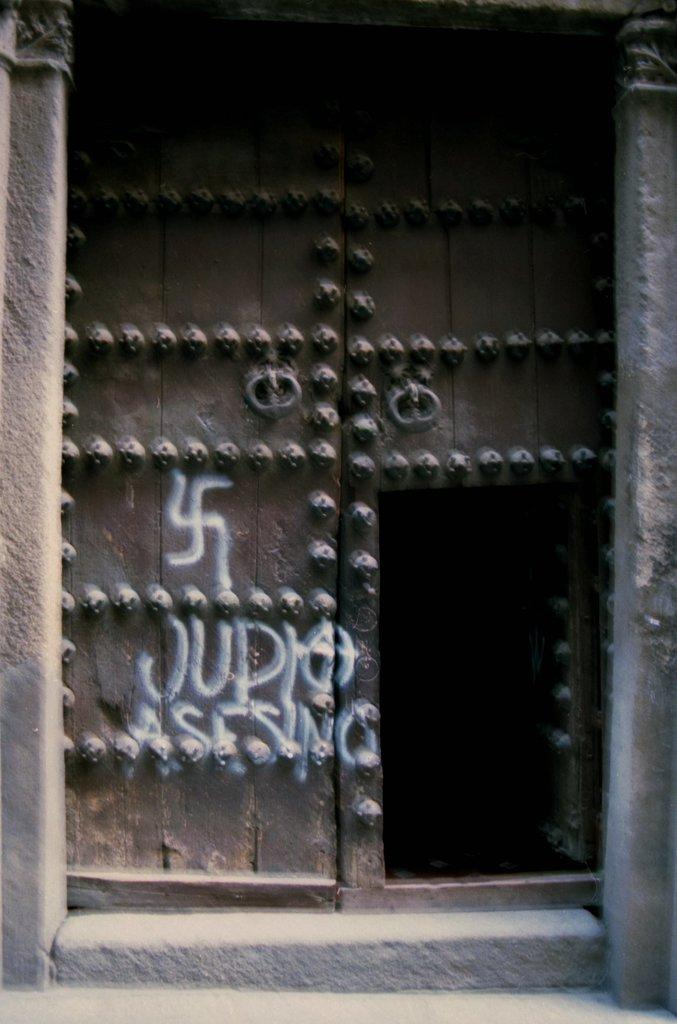What can be found in the image? There is a door in the image. What is written on the door? There is text written on the door. How many dimes are placed on the door in the image? There are no dimes present on the door in the image. What type of needle is used to write the text on the door? There is no needle used to write the text on the door; it is likely written with a pen or marker. 